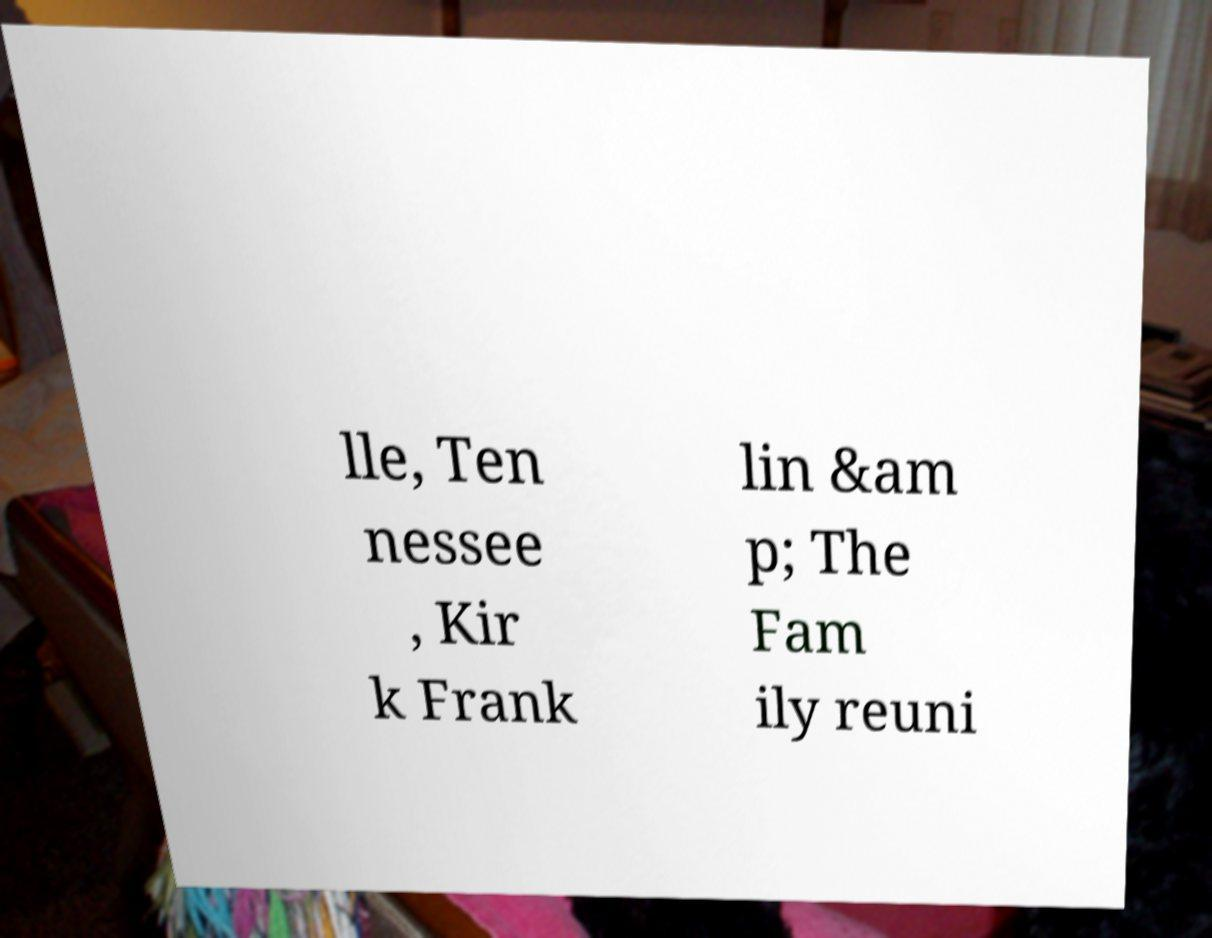There's text embedded in this image that I need extracted. Can you transcribe it verbatim? lle, Ten nessee , Kir k Frank lin &am p; The Fam ily reuni 